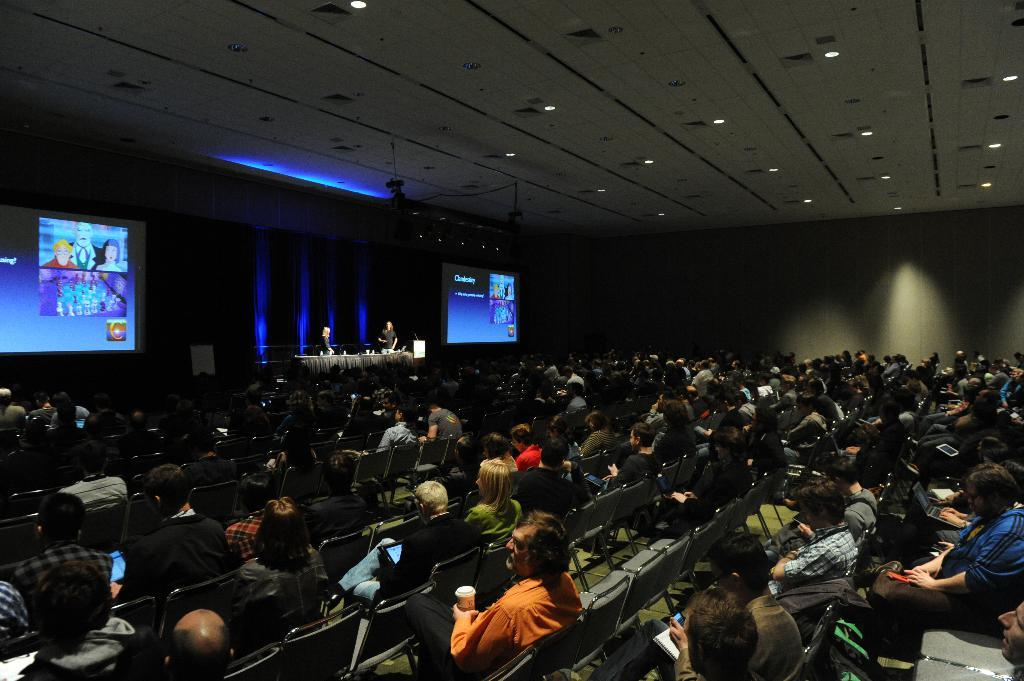What are the people in the image doing? The people in the image are sitting on chairs. What can be seen at the top of the image? There are lights visible at the top of the image. What is depicted on the wall in the image? There is a depiction on the wall in the image. How does the cannon affect the connection between the people in the image? There is no cannon present in the image, so it cannot affect any connections between the people. 